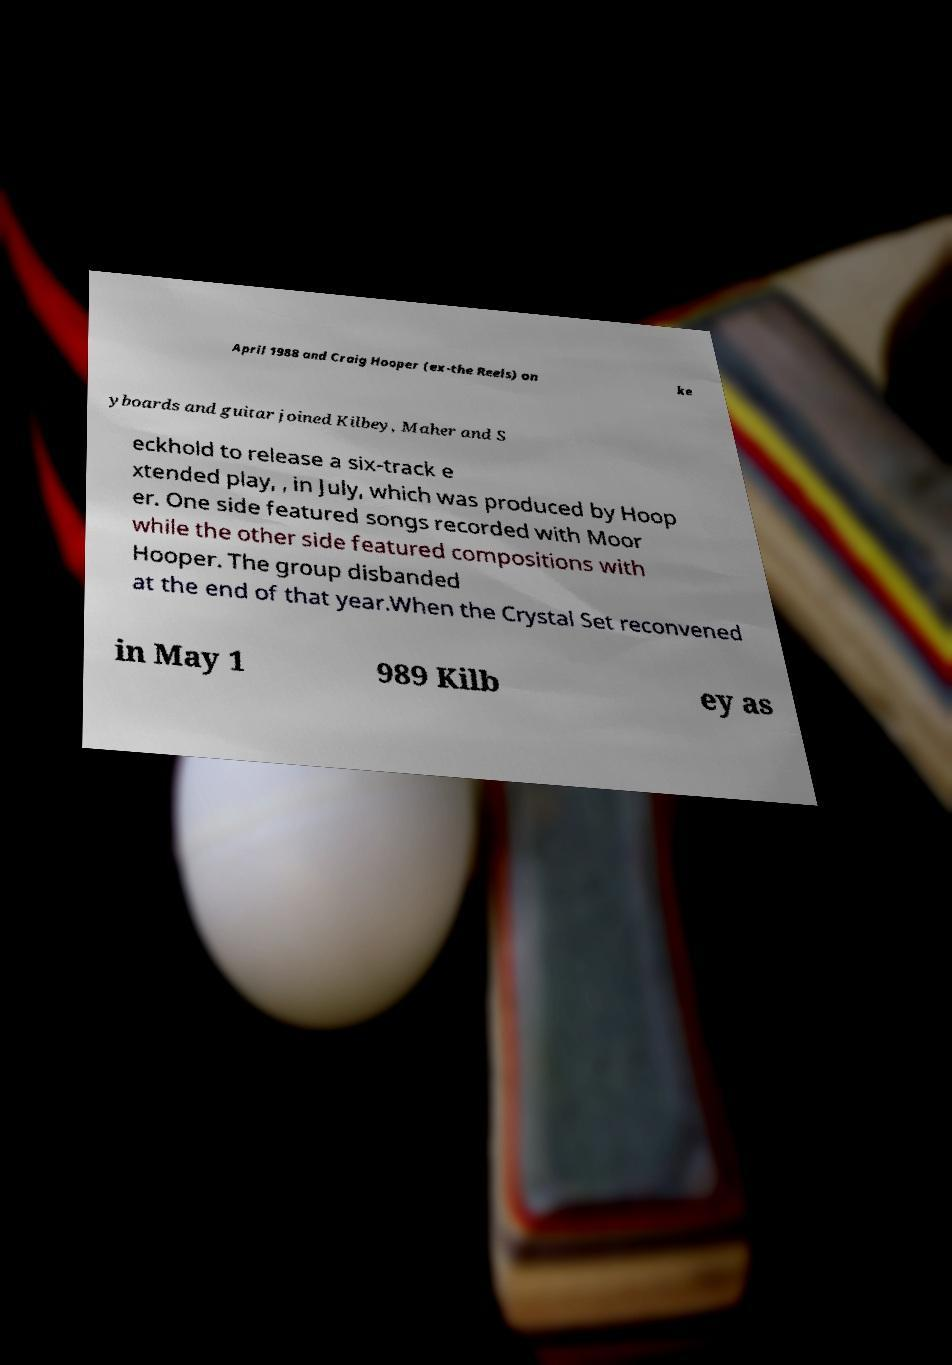Can you accurately transcribe the text from the provided image for me? April 1988 and Craig Hooper (ex-the Reels) on ke yboards and guitar joined Kilbey, Maher and S eckhold to release a six-track e xtended play, , in July, which was produced by Hoop er. One side featured songs recorded with Moor while the other side featured compositions with Hooper. The group disbanded at the end of that year.When the Crystal Set reconvened in May 1 989 Kilb ey as 